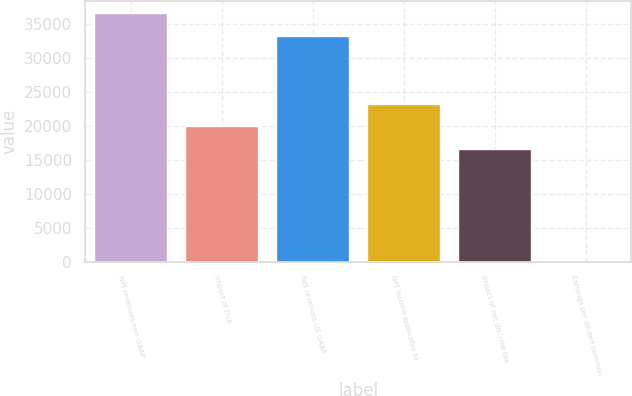Convert chart. <chart><loc_0><loc_0><loc_500><loc_500><bar_chart><fcel>Net revenues-non-GAAP<fcel>Impact of DVA<fcel>Net revenues-US GAAP<fcel>Net income applicable to<fcel>Impact of net discrete tax<fcel>Earnings per diluted common<nl><fcel>36491.2<fcel>19904.9<fcel>33174<fcel>23222.2<fcel>16587.7<fcel>1.36<nl></chart> 